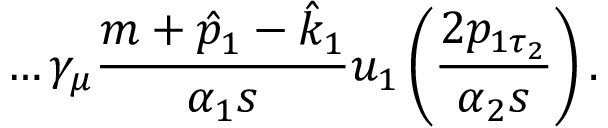Convert formula to latex. <formula><loc_0><loc_0><loc_500><loc_500>\dots \gamma _ { \mu } \frac { m + \hat { p } _ { 1 } - \hat { k } _ { 1 } } { \alpha _ { 1 } s } u _ { 1 } \left ( \frac { 2 p _ { 1 \tau _ { 2 } } } { \alpha _ { 2 } s } \right ) .</formula> 